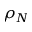Convert formula to latex. <formula><loc_0><loc_0><loc_500><loc_500>\rho _ { N }</formula> 